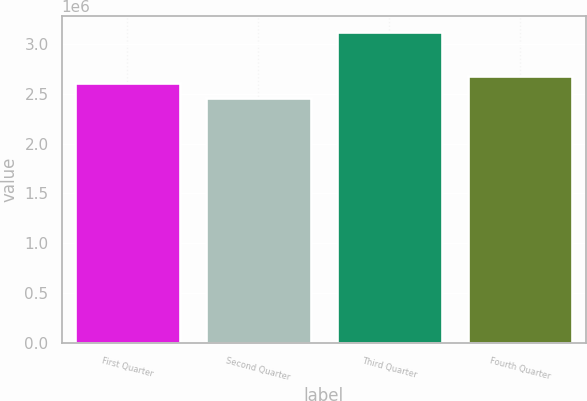Convert chart. <chart><loc_0><loc_0><loc_500><loc_500><bar_chart><fcel>First Quarter<fcel>Second Quarter<fcel>Third Quarter<fcel>Fourth Quarter<nl><fcel>2.60985e+06<fcel>2.46256e+06<fcel>3.1247e+06<fcel>2.67607e+06<nl></chart> 